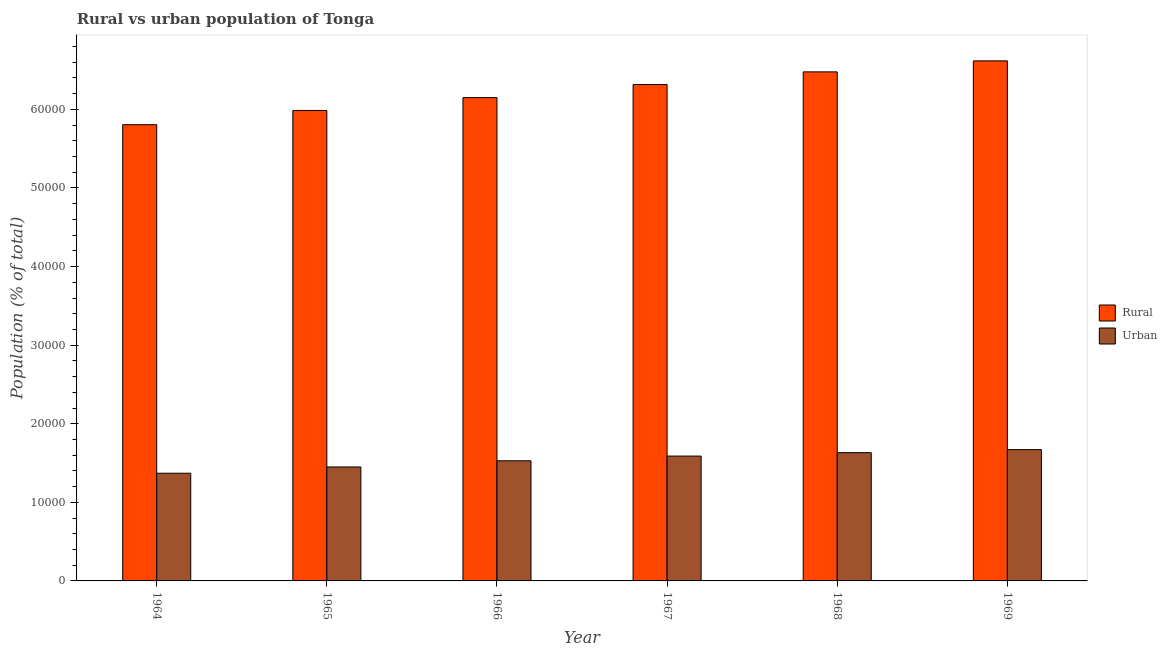How many different coloured bars are there?
Ensure brevity in your answer.  2. How many groups of bars are there?
Provide a short and direct response. 6. Are the number of bars per tick equal to the number of legend labels?
Your response must be concise. Yes. How many bars are there on the 5th tick from the right?
Offer a terse response. 2. What is the label of the 6th group of bars from the left?
Give a very brief answer. 1969. In how many cases, is the number of bars for a given year not equal to the number of legend labels?
Offer a terse response. 0. What is the urban population density in 1967?
Provide a succinct answer. 1.59e+04. Across all years, what is the maximum rural population density?
Your answer should be very brief. 6.62e+04. Across all years, what is the minimum rural population density?
Offer a terse response. 5.81e+04. In which year was the urban population density maximum?
Give a very brief answer. 1969. In which year was the urban population density minimum?
Provide a succinct answer. 1964. What is the total rural population density in the graph?
Provide a short and direct response. 3.74e+05. What is the difference between the urban population density in 1965 and that in 1967?
Offer a very short reply. -1386. What is the difference between the rural population density in 1968 and the urban population density in 1964?
Your answer should be very brief. 6721. What is the average rural population density per year?
Ensure brevity in your answer.  6.23e+04. In the year 1964, what is the difference between the rural population density and urban population density?
Ensure brevity in your answer.  0. In how many years, is the rural population density greater than 12000 %?
Give a very brief answer. 6. What is the ratio of the urban population density in 1965 to that in 1967?
Give a very brief answer. 0.91. Is the urban population density in 1966 less than that in 1967?
Offer a terse response. Yes. What is the difference between the highest and the second highest urban population density?
Make the answer very short. 384. What is the difference between the highest and the lowest urban population density?
Provide a short and direct response. 3002. Is the sum of the urban population density in 1965 and 1968 greater than the maximum rural population density across all years?
Offer a very short reply. Yes. What does the 2nd bar from the left in 1965 represents?
Keep it short and to the point. Urban. What does the 1st bar from the right in 1969 represents?
Offer a terse response. Urban. How many bars are there?
Offer a very short reply. 12. Are all the bars in the graph horizontal?
Keep it short and to the point. No. Does the graph contain any zero values?
Provide a short and direct response. No. Where does the legend appear in the graph?
Give a very brief answer. Center right. How are the legend labels stacked?
Keep it short and to the point. Vertical. What is the title of the graph?
Your response must be concise. Rural vs urban population of Tonga. Does "Measles" appear as one of the legend labels in the graph?
Your answer should be very brief. No. What is the label or title of the X-axis?
Keep it short and to the point. Year. What is the label or title of the Y-axis?
Your answer should be very brief. Population (% of total). What is the Population (% of total) of Rural in 1964?
Your answer should be very brief. 5.81e+04. What is the Population (% of total) of Urban in 1964?
Your answer should be compact. 1.37e+04. What is the Population (% of total) of Rural in 1965?
Your answer should be very brief. 5.99e+04. What is the Population (% of total) of Urban in 1965?
Provide a succinct answer. 1.45e+04. What is the Population (% of total) of Rural in 1966?
Offer a very short reply. 6.15e+04. What is the Population (% of total) in Urban in 1966?
Offer a terse response. 1.53e+04. What is the Population (% of total) of Rural in 1967?
Your answer should be compact. 6.32e+04. What is the Population (% of total) in Urban in 1967?
Provide a short and direct response. 1.59e+04. What is the Population (% of total) in Rural in 1968?
Offer a very short reply. 6.48e+04. What is the Population (% of total) of Urban in 1968?
Provide a short and direct response. 1.63e+04. What is the Population (% of total) of Rural in 1969?
Offer a terse response. 6.62e+04. What is the Population (% of total) in Urban in 1969?
Ensure brevity in your answer.  1.67e+04. Across all years, what is the maximum Population (% of total) of Rural?
Offer a terse response. 6.62e+04. Across all years, what is the maximum Population (% of total) in Urban?
Your response must be concise. 1.67e+04. Across all years, what is the minimum Population (% of total) in Rural?
Your answer should be very brief. 5.81e+04. Across all years, what is the minimum Population (% of total) of Urban?
Make the answer very short. 1.37e+04. What is the total Population (% of total) of Rural in the graph?
Provide a short and direct response. 3.74e+05. What is the total Population (% of total) of Urban in the graph?
Provide a short and direct response. 9.24e+04. What is the difference between the Population (% of total) of Rural in 1964 and that in 1965?
Offer a terse response. -1810. What is the difference between the Population (% of total) in Urban in 1964 and that in 1965?
Your answer should be compact. -796. What is the difference between the Population (% of total) in Rural in 1964 and that in 1966?
Keep it short and to the point. -3447. What is the difference between the Population (% of total) of Urban in 1964 and that in 1966?
Give a very brief answer. -1583. What is the difference between the Population (% of total) of Rural in 1964 and that in 1967?
Keep it short and to the point. -5109. What is the difference between the Population (% of total) in Urban in 1964 and that in 1967?
Your response must be concise. -2182. What is the difference between the Population (% of total) of Rural in 1964 and that in 1968?
Provide a short and direct response. -6721. What is the difference between the Population (% of total) of Urban in 1964 and that in 1968?
Ensure brevity in your answer.  -2618. What is the difference between the Population (% of total) of Rural in 1964 and that in 1969?
Offer a terse response. -8120. What is the difference between the Population (% of total) in Urban in 1964 and that in 1969?
Your answer should be very brief. -3002. What is the difference between the Population (% of total) in Rural in 1965 and that in 1966?
Provide a succinct answer. -1637. What is the difference between the Population (% of total) in Urban in 1965 and that in 1966?
Give a very brief answer. -787. What is the difference between the Population (% of total) of Rural in 1965 and that in 1967?
Offer a very short reply. -3299. What is the difference between the Population (% of total) of Urban in 1965 and that in 1967?
Keep it short and to the point. -1386. What is the difference between the Population (% of total) of Rural in 1965 and that in 1968?
Offer a very short reply. -4911. What is the difference between the Population (% of total) in Urban in 1965 and that in 1968?
Provide a succinct answer. -1822. What is the difference between the Population (% of total) in Rural in 1965 and that in 1969?
Provide a succinct answer. -6310. What is the difference between the Population (% of total) in Urban in 1965 and that in 1969?
Your response must be concise. -2206. What is the difference between the Population (% of total) of Rural in 1966 and that in 1967?
Ensure brevity in your answer.  -1662. What is the difference between the Population (% of total) of Urban in 1966 and that in 1967?
Ensure brevity in your answer.  -599. What is the difference between the Population (% of total) of Rural in 1966 and that in 1968?
Give a very brief answer. -3274. What is the difference between the Population (% of total) of Urban in 1966 and that in 1968?
Your answer should be compact. -1035. What is the difference between the Population (% of total) of Rural in 1966 and that in 1969?
Keep it short and to the point. -4673. What is the difference between the Population (% of total) in Urban in 1966 and that in 1969?
Make the answer very short. -1419. What is the difference between the Population (% of total) in Rural in 1967 and that in 1968?
Give a very brief answer. -1612. What is the difference between the Population (% of total) of Urban in 1967 and that in 1968?
Your response must be concise. -436. What is the difference between the Population (% of total) of Rural in 1967 and that in 1969?
Keep it short and to the point. -3011. What is the difference between the Population (% of total) of Urban in 1967 and that in 1969?
Keep it short and to the point. -820. What is the difference between the Population (% of total) of Rural in 1968 and that in 1969?
Your answer should be very brief. -1399. What is the difference between the Population (% of total) in Urban in 1968 and that in 1969?
Provide a short and direct response. -384. What is the difference between the Population (% of total) in Rural in 1964 and the Population (% of total) in Urban in 1965?
Your response must be concise. 4.36e+04. What is the difference between the Population (% of total) in Rural in 1964 and the Population (% of total) in Urban in 1966?
Give a very brief answer. 4.28e+04. What is the difference between the Population (% of total) in Rural in 1964 and the Population (% of total) in Urban in 1967?
Offer a terse response. 4.22e+04. What is the difference between the Population (% of total) of Rural in 1964 and the Population (% of total) of Urban in 1968?
Offer a terse response. 4.17e+04. What is the difference between the Population (% of total) of Rural in 1964 and the Population (% of total) of Urban in 1969?
Your answer should be very brief. 4.13e+04. What is the difference between the Population (% of total) in Rural in 1965 and the Population (% of total) in Urban in 1966?
Keep it short and to the point. 4.46e+04. What is the difference between the Population (% of total) of Rural in 1965 and the Population (% of total) of Urban in 1967?
Your response must be concise. 4.40e+04. What is the difference between the Population (% of total) of Rural in 1965 and the Population (% of total) of Urban in 1968?
Your answer should be very brief. 4.35e+04. What is the difference between the Population (% of total) of Rural in 1965 and the Population (% of total) of Urban in 1969?
Give a very brief answer. 4.32e+04. What is the difference between the Population (% of total) of Rural in 1966 and the Population (% of total) of Urban in 1967?
Offer a terse response. 4.56e+04. What is the difference between the Population (% of total) of Rural in 1966 and the Population (% of total) of Urban in 1968?
Your answer should be very brief. 4.52e+04. What is the difference between the Population (% of total) of Rural in 1966 and the Population (% of total) of Urban in 1969?
Ensure brevity in your answer.  4.48e+04. What is the difference between the Population (% of total) in Rural in 1967 and the Population (% of total) in Urban in 1968?
Provide a short and direct response. 4.68e+04. What is the difference between the Population (% of total) of Rural in 1967 and the Population (% of total) of Urban in 1969?
Keep it short and to the point. 4.65e+04. What is the difference between the Population (% of total) in Rural in 1968 and the Population (% of total) in Urban in 1969?
Ensure brevity in your answer.  4.81e+04. What is the average Population (% of total) of Rural per year?
Your answer should be very brief. 6.23e+04. What is the average Population (% of total) of Urban per year?
Ensure brevity in your answer.  1.54e+04. In the year 1964, what is the difference between the Population (% of total) in Rural and Population (% of total) in Urban?
Your answer should be very brief. 4.43e+04. In the year 1965, what is the difference between the Population (% of total) in Rural and Population (% of total) in Urban?
Make the answer very short. 4.54e+04. In the year 1966, what is the difference between the Population (% of total) in Rural and Population (% of total) in Urban?
Provide a succinct answer. 4.62e+04. In the year 1967, what is the difference between the Population (% of total) in Rural and Population (% of total) in Urban?
Ensure brevity in your answer.  4.73e+04. In the year 1968, what is the difference between the Population (% of total) in Rural and Population (% of total) in Urban?
Ensure brevity in your answer.  4.85e+04. In the year 1969, what is the difference between the Population (% of total) in Rural and Population (% of total) in Urban?
Offer a terse response. 4.95e+04. What is the ratio of the Population (% of total) in Rural in 1964 to that in 1965?
Give a very brief answer. 0.97. What is the ratio of the Population (% of total) in Urban in 1964 to that in 1965?
Offer a terse response. 0.95. What is the ratio of the Population (% of total) of Rural in 1964 to that in 1966?
Give a very brief answer. 0.94. What is the ratio of the Population (% of total) in Urban in 1964 to that in 1966?
Offer a terse response. 0.9. What is the ratio of the Population (% of total) of Rural in 1964 to that in 1967?
Keep it short and to the point. 0.92. What is the ratio of the Population (% of total) in Urban in 1964 to that in 1967?
Your answer should be very brief. 0.86. What is the ratio of the Population (% of total) of Rural in 1964 to that in 1968?
Offer a very short reply. 0.9. What is the ratio of the Population (% of total) in Urban in 1964 to that in 1968?
Provide a succinct answer. 0.84. What is the ratio of the Population (% of total) in Rural in 1964 to that in 1969?
Your answer should be very brief. 0.88. What is the ratio of the Population (% of total) of Urban in 1964 to that in 1969?
Offer a terse response. 0.82. What is the ratio of the Population (% of total) in Rural in 1965 to that in 1966?
Offer a terse response. 0.97. What is the ratio of the Population (% of total) in Urban in 1965 to that in 1966?
Offer a terse response. 0.95. What is the ratio of the Population (% of total) in Rural in 1965 to that in 1967?
Offer a very short reply. 0.95. What is the ratio of the Population (% of total) in Urban in 1965 to that in 1967?
Offer a very short reply. 0.91. What is the ratio of the Population (% of total) of Rural in 1965 to that in 1968?
Keep it short and to the point. 0.92. What is the ratio of the Population (% of total) of Urban in 1965 to that in 1968?
Offer a very short reply. 0.89. What is the ratio of the Population (% of total) in Rural in 1965 to that in 1969?
Your response must be concise. 0.9. What is the ratio of the Population (% of total) of Urban in 1965 to that in 1969?
Give a very brief answer. 0.87. What is the ratio of the Population (% of total) in Rural in 1966 to that in 1967?
Offer a very short reply. 0.97. What is the ratio of the Population (% of total) of Urban in 1966 to that in 1967?
Give a very brief answer. 0.96. What is the ratio of the Population (% of total) in Rural in 1966 to that in 1968?
Offer a terse response. 0.95. What is the ratio of the Population (% of total) in Urban in 1966 to that in 1968?
Your answer should be compact. 0.94. What is the ratio of the Population (% of total) of Rural in 1966 to that in 1969?
Your answer should be compact. 0.93. What is the ratio of the Population (% of total) in Urban in 1966 to that in 1969?
Make the answer very short. 0.92. What is the ratio of the Population (% of total) in Rural in 1967 to that in 1968?
Ensure brevity in your answer.  0.98. What is the ratio of the Population (% of total) in Urban in 1967 to that in 1968?
Provide a short and direct response. 0.97. What is the ratio of the Population (% of total) of Rural in 1967 to that in 1969?
Your answer should be very brief. 0.95. What is the ratio of the Population (% of total) of Urban in 1967 to that in 1969?
Provide a short and direct response. 0.95. What is the ratio of the Population (% of total) in Rural in 1968 to that in 1969?
Make the answer very short. 0.98. What is the ratio of the Population (% of total) of Urban in 1968 to that in 1969?
Make the answer very short. 0.98. What is the difference between the highest and the second highest Population (% of total) of Rural?
Provide a succinct answer. 1399. What is the difference between the highest and the second highest Population (% of total) of Urban?
Offer a terse response. 384. What is the difference between the highest and the lowest Population (% of total) of Rural?
Make the answer very short. 8120. What is the difference between the highest and the lowest Population (% of total) in Urban?
Give a very brief answer. 3002. 